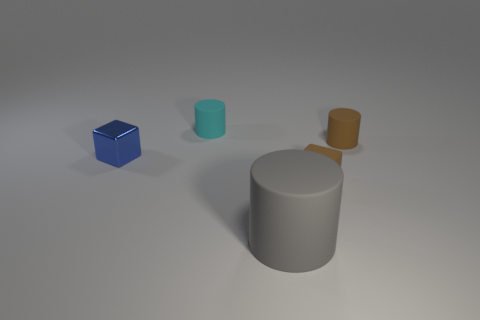Subtract all cyan cylinders. How many cylinders are left? 2 Subtract 1 cylinders. How many cylinders are left? 2 Add 5 tiny gray balls. How many objects exist? 10 Subtract all cyan cylinders. How many cylinders are left? 2 Subtract all red cubes. How many brown cylinders are left? 1 Subtract all tiny brown cubes. Subtract all matte cubes. How many objects are left? 3 Add 2 tiny blue cubes. How many tiny blue cubes are left? 3 Add 5 brown matte cylinders. How many brown matte cylinders exist? 6 Subtract 1 gray cylinders. How many objects are left? 4 Subtract all cubes. How many objects are left? 3 